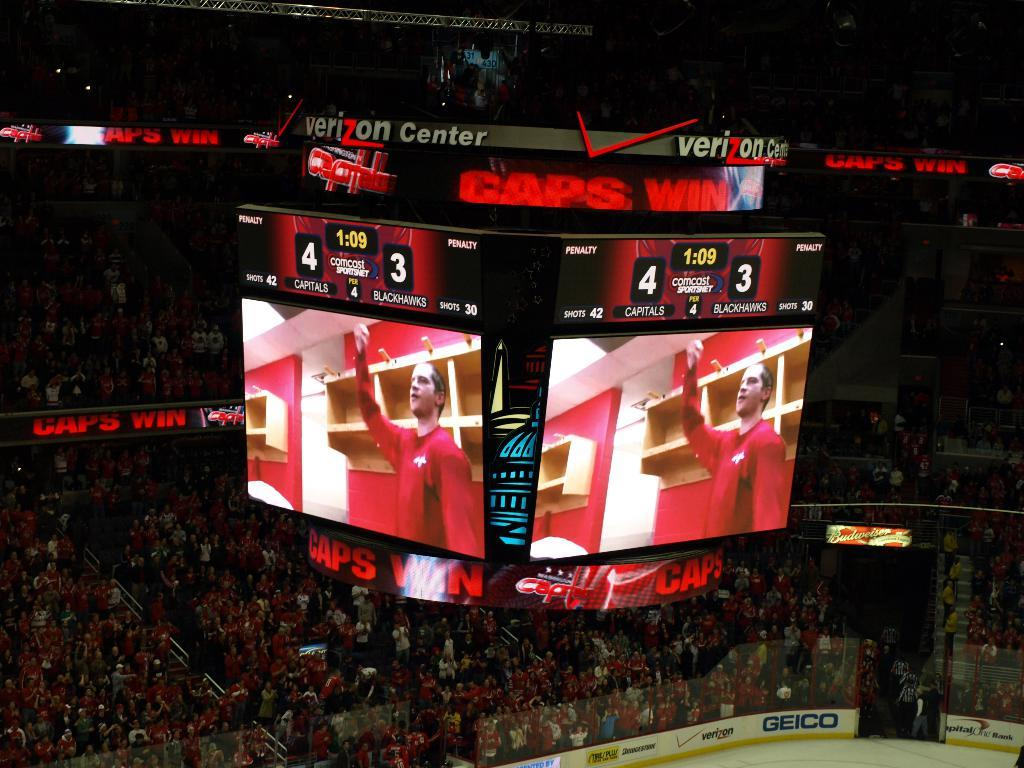<image>
Summarize the visual content of the image. Hockey game jumbo tron screen that says score 4-3 with the words Verizon Center on top. 